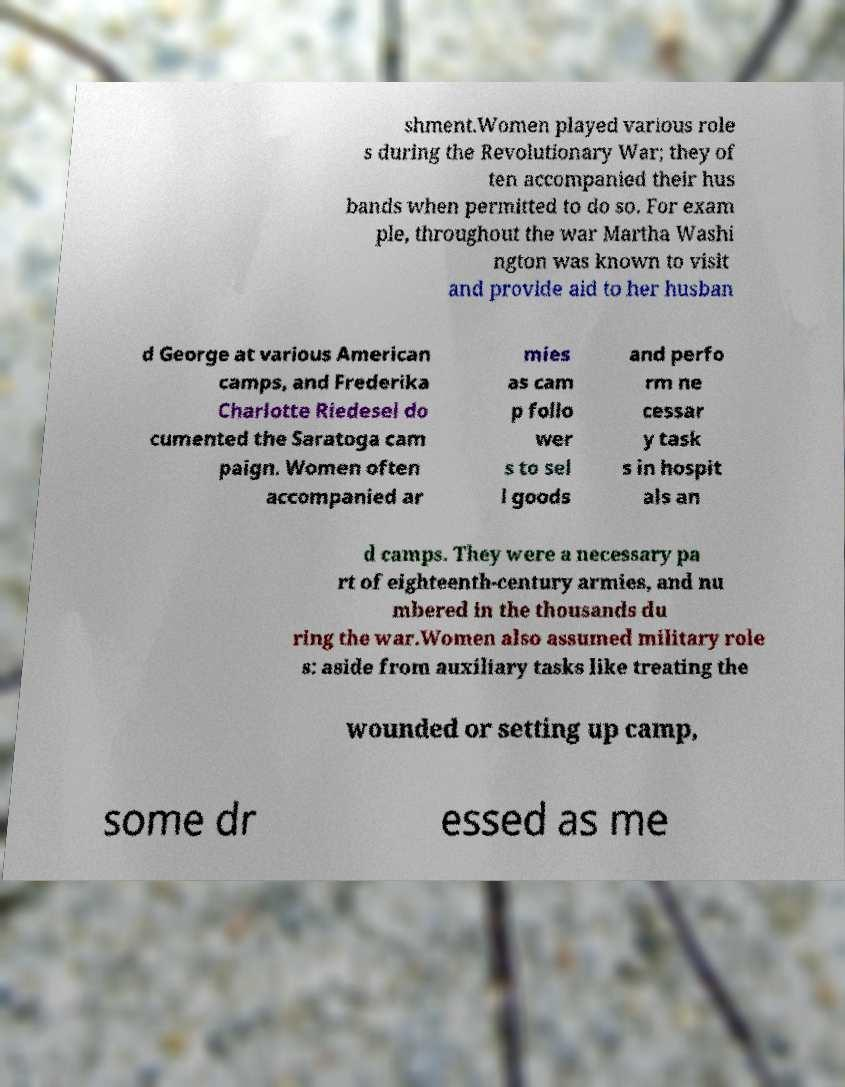There's text embedded in this image that I need extracted. Can you transcribe it verbatim? shment.Women played various role s during the Revolutionary War; they of ten accompanied their hus bands when permitted to do so. For exam ple, throughout the war Martha Washi ngton was known to visit and provide aid to her husban d George at various American camps, and Frederika Charlotte Riedesel do cumented the Saratoga cam paign. Women often accompanied ar mies as cam p follo wer s to sel l goods and perfo rm ne cessar y task s in hospit als an d camps. They were a necessary pa rt of eighteenth-century armies, and nu mbered in the thousands du ring the war.Women also assumed military role s: aside from auxiliary tasks like treating the wounded or setting up camp, some dr essed as me 